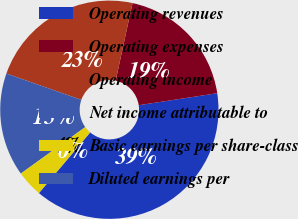Convert chart to OTSL. <chart><loc_0><loc_0><loc_500><loc_500><pie_chart><fcel>Operating revenues<fcel>Operating expenses<fcel>Operating income<fcel>Net income attributable to<fcel>Basic earnings per share-class<fcel>Diluted earnings per<nl><fcel>38.57%<fcel>19.18%<fcel>23.03%<fcel>15.32%<fcel>3.88%<fcel>0.02%<nl></chart> 